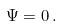<formula> <loc_0><loc_0><loc_500><loc_500>\Psi = 0 \, .</formula> 